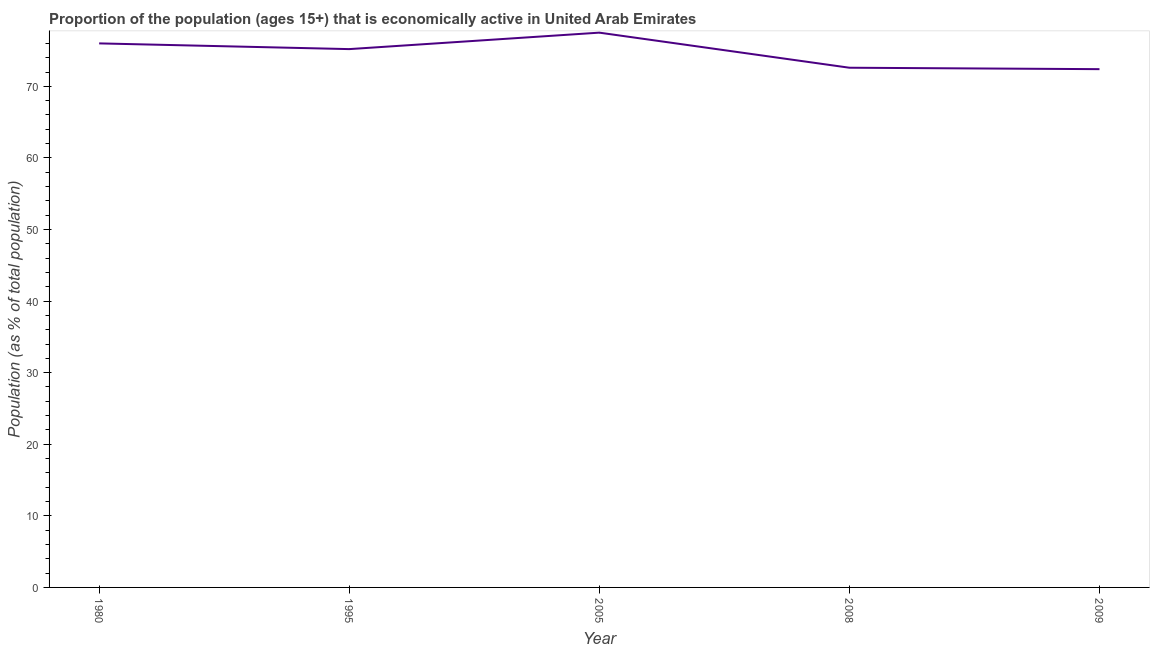What is the percentage of economically active population in 2009?
Offer a very short reply. 72.4. Across all years, what is the maximum percentage of economically active population?
Provide a short and direct response. 77.5. Across all years, what is the minimum percentage of economically active population?
Ensure brevity in your answer.  72.4. In which year was the percentage of economically active population maximum?
Your answer should be compact. 2005. What is the sum of the percentage of economically active population?
Provide a succinct answer. 373.7. What is the difference between the percentage of economically active population in 2005 and 2008?
Offer a very short reply. 4.9. What is the average percentage of economically active population per year?
Provide a succinct answer. 74.74. What is the median percentage of economically active population?
Provide a succinct answer. 75.2. In how many years, is the percentage of economically active population greater than 52 %?
Keep it short and to the point. 5. Do a majority of the years between 2009 and 2005 (inclusive) have percentage of economically active population greater than 60 %?
Provide a short and direct response. No. What is the ratio of the percentage of economically active population in 1995 to that in 2008?
Give a very brief answer. 1.04. Is the percentage of economically active population in 2005 less than that in 2009?
Make the answer very short. No. What is the difference between the highest and the lowest percentage of economically active population?
Provide a succinct answer. 5.1. In how many years, is the percentage of economically active population greater than the average percentage of economically active population taken over all years?
Provide a short and direct response. 3. How many years are there in the graph?
Your answer should be compact. 5. What is the difference between two consecutive major ticks on the Y-axis?
Your answer should be very brief. 10. Does the graph contain any zero values?
Keep it short and to the point. No. What is the title of the graph?
Keep it short and to the point. Proportion of the population (ages 15+) that is economically active in United Arab Emirates. What is the label or title of the X-axis?
Ensure brevity in your answer.  Year. What is the label or title of the Y-axis?
Offer a terse response. Population (as % of total population). What is the Population (as % of total population) of 1980?
Provide a succinct answer. 76. What is the Population (as % of total population) in 1995?
Your answer should be compact. 75.2. What is the Population (as % of total population) in 2005?
Offer a very short reply. 77.5. What is the Population (as % of total population) in 2008?
Keep it short and to the point. 72.6. What is the Population (as % of total population) of 2009?
Your response must be concise. 72.4. What is the difference between the Population (as % of total population) in 1980 and 2005?
Your response must be concise. -1.5. What is the difference between the Population (as % of total population) in 1980 and 2008?
Make the answer very short. 3.4. What is the difference between the Population (as % of total population) in 1980 and 2009?
Provide a succinct answer. 3.6. What is the difference between the Population (as % of total population) in 1995 and 2005?
Your answer should be compact. -2.3. What is the difference between the Population (as % of total population) in 1995 and 2009?
Make the answer very short. 2.8. What is the difference between the Population (as % of total population) in 2005 and 2009?
Keep it short and to the point. 5.1. What is the difference between the Population (as % of total population) in 2008 and 2009?
Your answer should be compact. 0.2. What is the ratio of the Population (as % of total population) in 1980 to that in 2008?
Your response must be concise. 1.05. What is the ratio of the Population (as % of total population) in 1980 to that in 2009?
Ensure brevity in your answer.  1.05. What is the ratio of the Population (as % of total population) in 1995 to that in 2005?
Your response must be concise. 0.97. What is the ratio of the Population (as % of total population) in 1995 to that in 2008?
Give a very brief answer. 1.04. What is the ratio of the Population (as % of total population) in 1995 to that in 2009?
Offer a very short reply. 1.04. What is the ratio of the Population (as % of total population) in 2005 to that in 2008?
Your answer should be compact. 1.07. What is the ratio of the Population (as % of total population) in 2005 to that in 2009?
Make the answer very short. 1.07. What is the ratio of the Population (as % of total population) in 2008 to that in 2009?
Give a very brief answer. 1. 